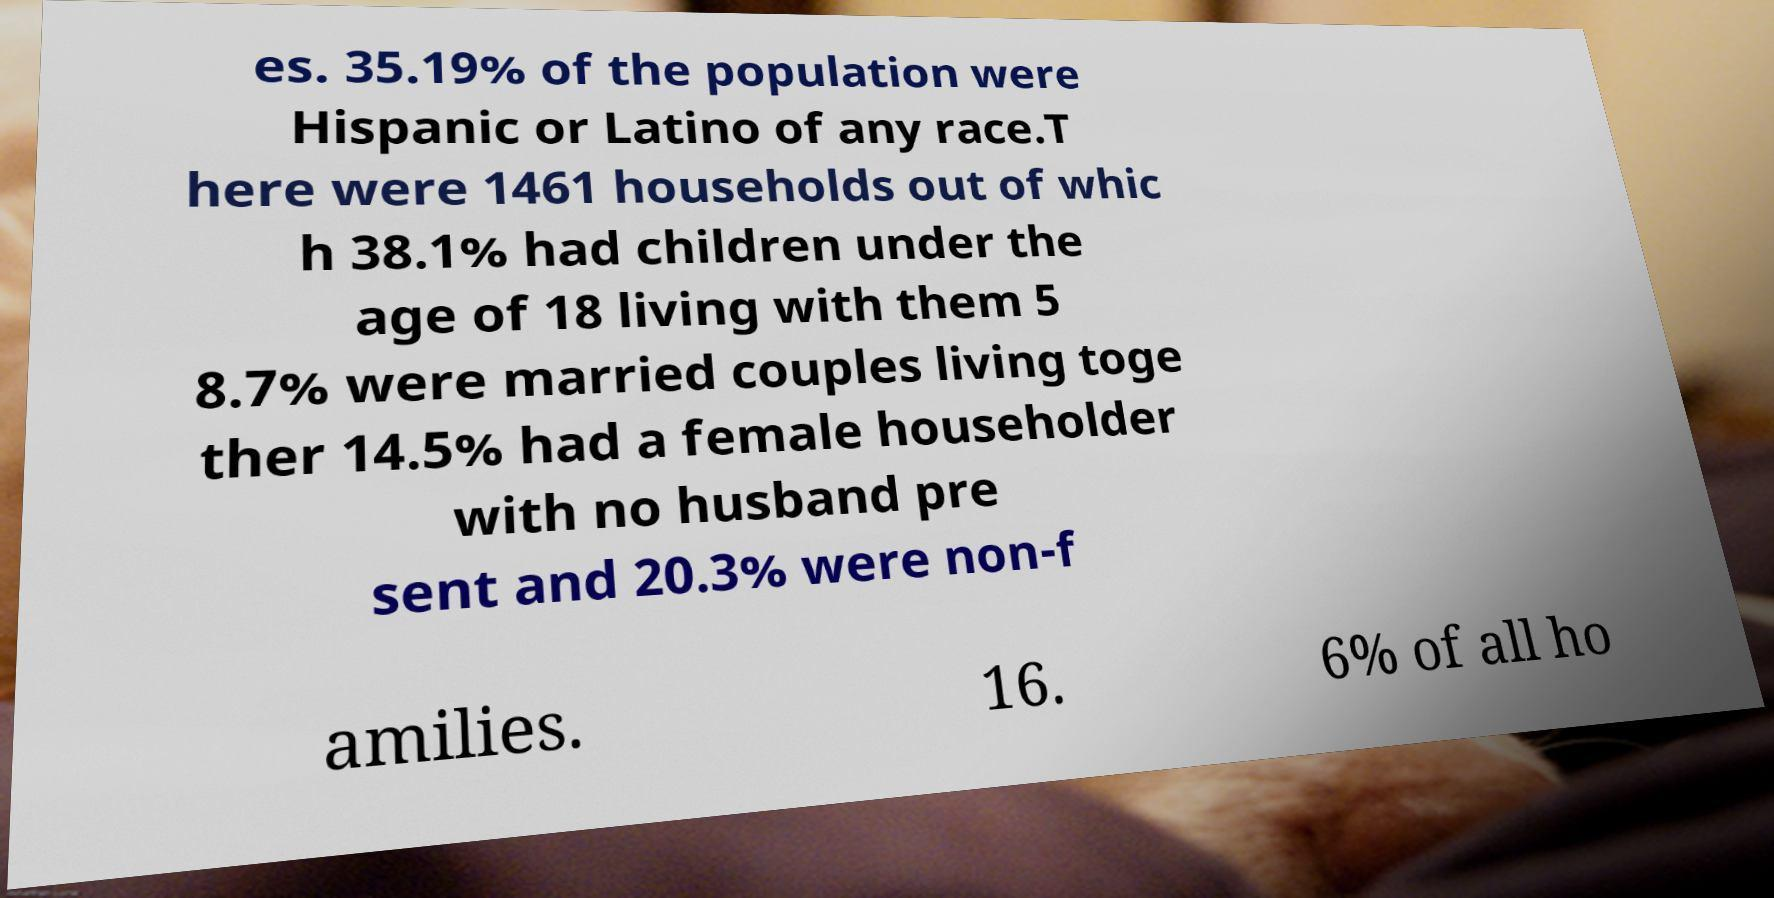Please read and relay the text visible in this image. What does it say? es. 35.19% of the population were Hispanic or Latino of any race.T here were 1461 households out of whic h 38.1% had children under the age of 18 living with them 5 8.7% were married couples living toge ther 14.5% had a female householder with no husband pre sent and 20.3% were non-f amilies. 16. 6% of all ho 